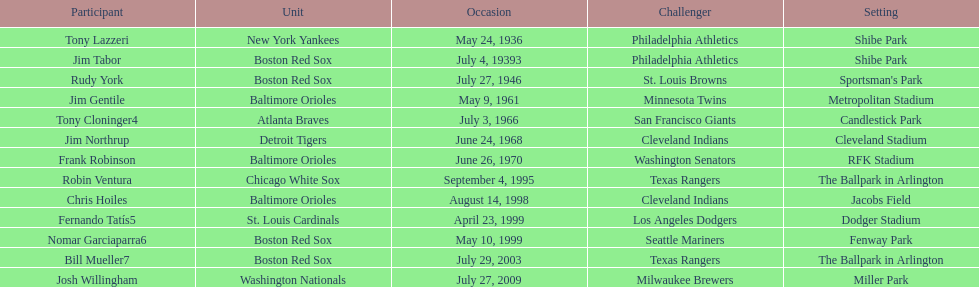Who is the first major league hitter to hit two grand slams in one game? Tony Lazzeri. 